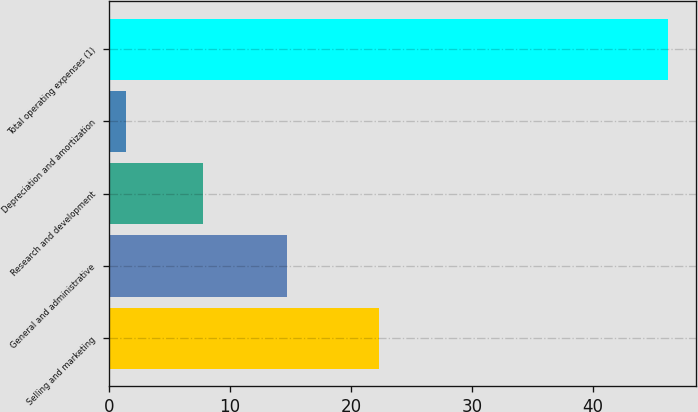<chart> <loc_0><loc_0><loc_500><loc_500><bar_chart><fcel>Selling and marketing<fcel>General and administrative<fcel>Research and development<fcel>Depreciation and amortization<fcel>Total operating expenses (1)<nl><fcel>22.3<fcel>14.7<fcel>7.8<fcel>1.4<fcel>46.2<nl></chart> 